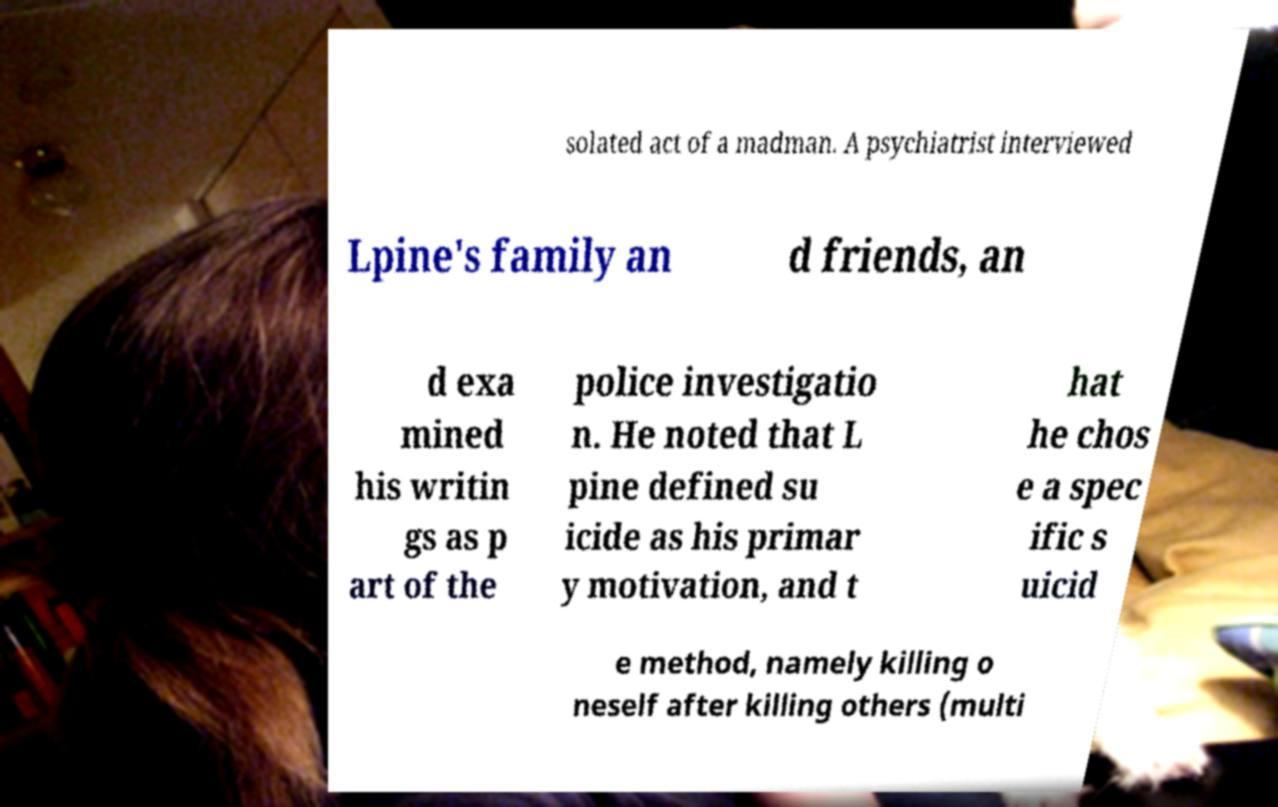Could you assist in decoding the text presented in this image and type it out clearly? solated act of a madman. A psychiatrist interviewed Lpine's family an d friends, an d exa mined his writin gs as p art of the police investigatio n. He noted that L pine defined su icide as his primar y motivation, and t hat he chos e a spec ific s uicid e method, namely killing o neself after killing others (multi 